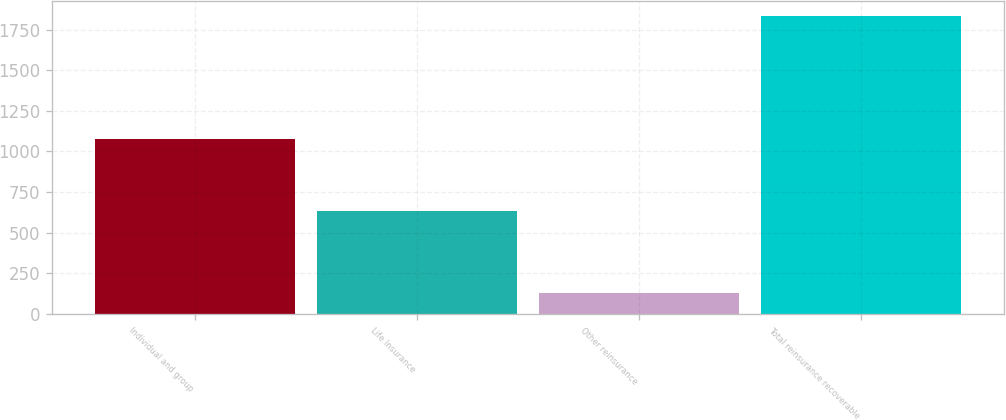<chart> <loc_0><loc_0><loc_500><loc_500><bar_chart><fcel>Individual and group<fcel>Life Insurance<fcel>Other reinsurance<fcel>Total reinsurance recoverable<nl><fcel>1075<fcel>635<fcel>127<fcel>1837<nl></chart> 